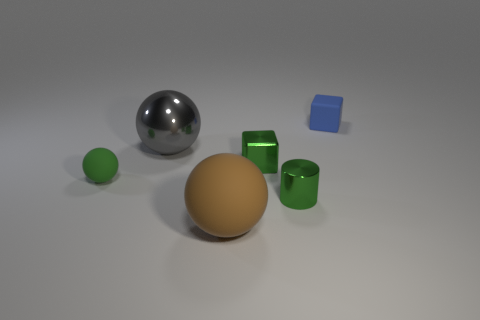What number of gray spheres are the same size as the brown object?
Offer a very short reply. 1. What number of objects are either gray metal objects or metal things to the left of the brown matte object?
Provide a succinct answer. 1. What is the shape of the small blue thing?
Provide a succinct answer. Cube. Do the big rubber object and the small metallic cylinder have the same color?
Keep it short and to the point. No. There is another metal thing that is the same size as the brown thing; what color is it?
Keep it short and to the point. Gray. What number of cyan objects are big spheres or tiny cubes?
Provide a short and direct response. 0. Are there more small blue cubes than big brown metallic cylinders?
Give a very brief answer. Yes. Do the object behind the big metal thing and the cube to the left of the blue rubber object have the same size?
Ensure brevity in your answer.  Yes. There is a tiny metallic thing behind the green thing on the left side of the cube that is in front of the small blue matte block; what is its color?
Give a very brief answer. Green. Is there another large gray object that has the same shape as the big gray thing?
Your answer should be very brief. No. 